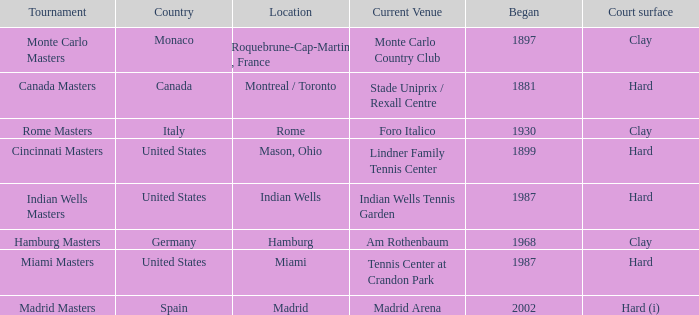Rome is in which country? Italy. 